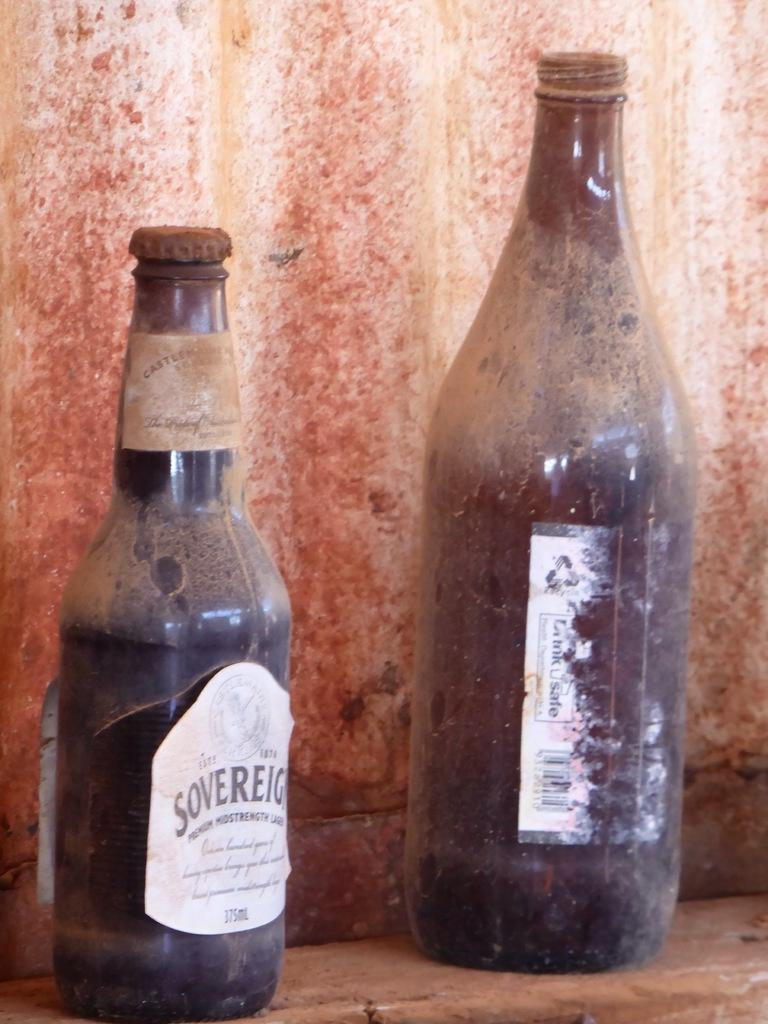How many bottles are visible in the image? There are two bottles in the image. Where are the bottles located in the image? The bottles are on the floor. How many boys are playing with the pig in the image? There are no boys or pigs present in the image; it only features two bottles on the floor. 